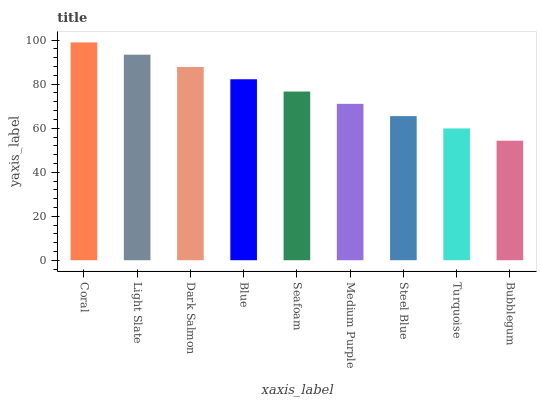Is Bubblegum the minimum?
Answer yes or no. Yes. Is Coral the maximum?
Answer yes or no. Yes. Is Light Slate the minimum?
Answer yes or no. No. Is Light Slate the maximum?
Answer yes or no. No. Is Coral greater than Light Slate?
Answer yes or no. Yes. Is Light Slate less than Coral?
Answer yes or no. Yes. Is Light Slate greater than Coral?
Answer yes or no. No. Is Coral less than Light Slate?
Answer yes or no. No. Is Seafoam the high median?
Answer yes or no. Yes. Is Seafoam the low median?
Answer yes or no. Yes. Is Steel Blue the high median?
Answer yes or no. No. Is Light Slate the low median?
Answer yes or no. No. 